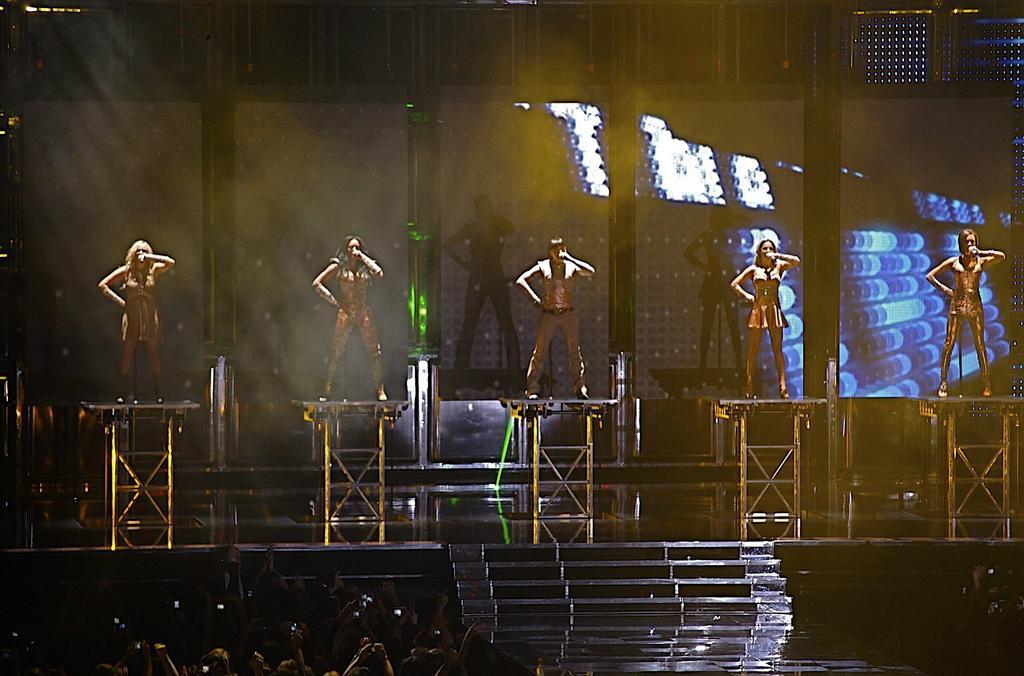How would you summarize this image in a sentence or two? In this image I can see few people are standing and holding something. They are standing on few strands and few strands are on the stage. I can see few people,stairs and few lights. Background is dark. 